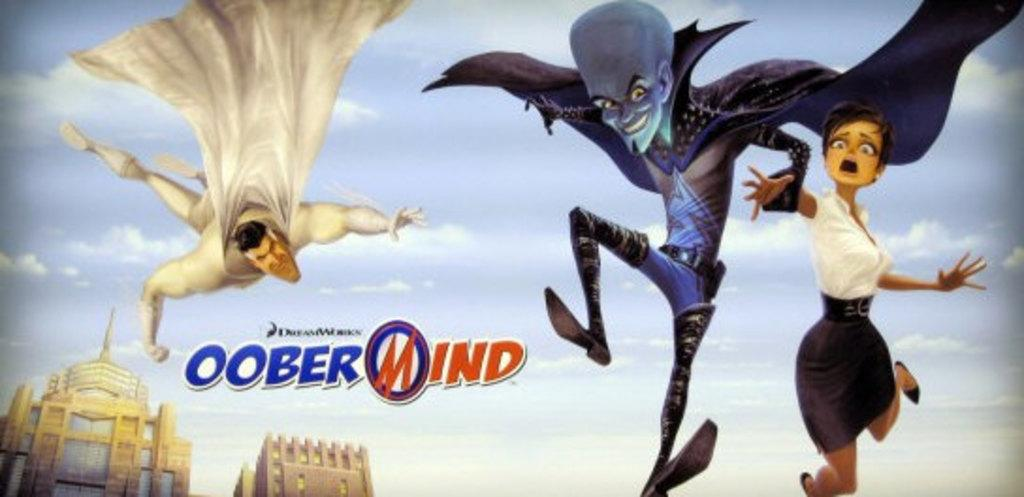<image>
Write a terse but informative summary of the picture. A movie for a Dreamworks animated movie showing a blue alien dragging a scared-looking woman along while a caped hero in white pursues them. 